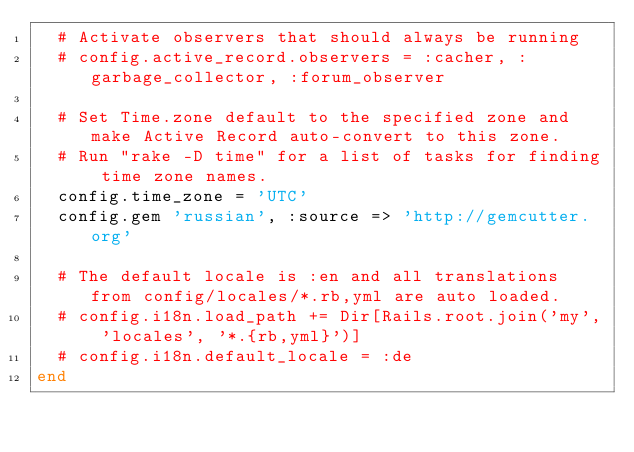<code> <loc_0><loc_0><loc_500><loc_500><_Ruby_>  # Activate observers that should always be running
  # config.active_record.observers = :cacher, :garbage_collector, :forum_observer

  # Set Time.zone default to the specified zone and make Active Record auto-convert to this zone.
  # Run "rake -D time" for a list of tasks for finding time zone names.
  config.time_zone = 'UTC'
  config.gem 'russian', :source => 'http://gemcutter.org'

  # The default locale is :en and all translations from config/locales/*.rb,yml are auto loaded.
  # config.i18n.load_path += Dir[Rails.root.join('my', 'locales', '*.{rb,yml}')]
  # config.i18n.default_locale = :de
end
</code> 